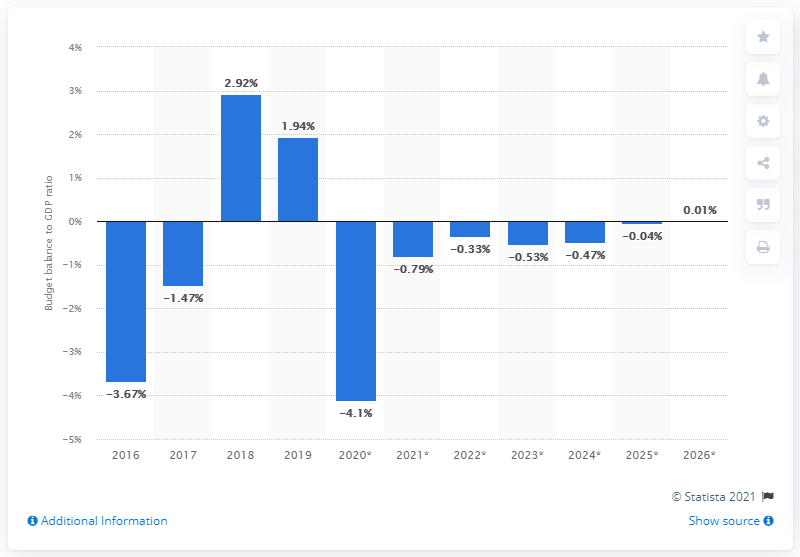Outline some significant characteristics in this image. In 2019, Russia's state surplus accounted for approximately 1.94% of the country's gross domestic product. 